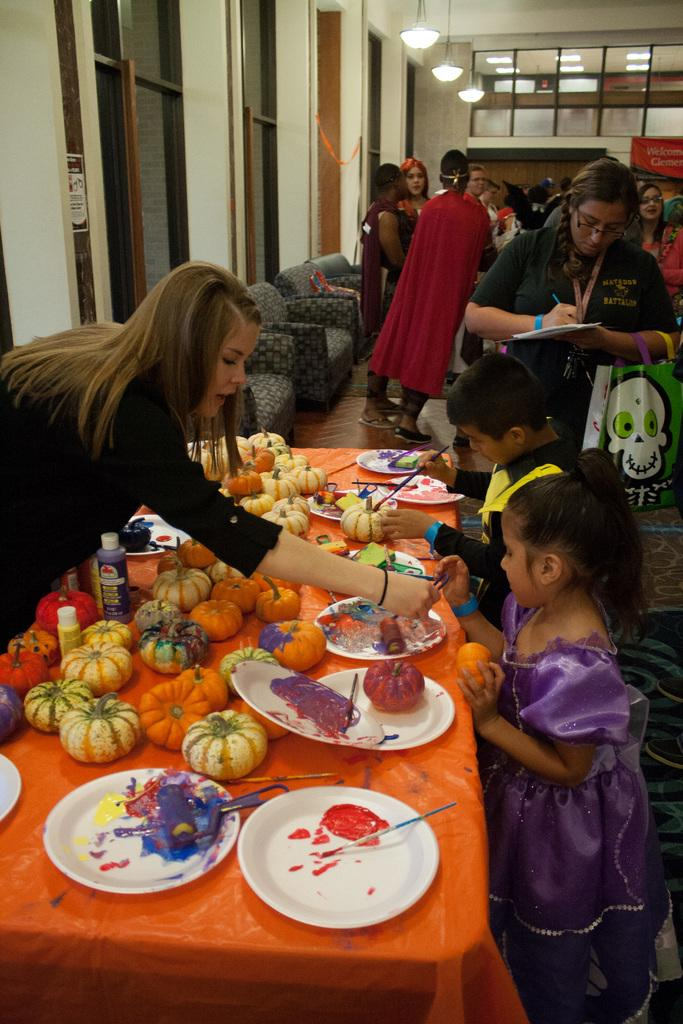What is the color of the wall in the image? The wall in the image is white. What can be seen in the image besides the wall? There are lights, people, sofas, a table, plates, colors, and pumpkins visible in the image. What type of furniture is present in the image? There are sofas in the image. What is on the table in the image? There are plates, colors, and pumpkins on the table in the image. What store can be seen in the image? There is no store present in the image. What is the best way to reach the afterthought in the image? There is no afterthought present in the image, so it cannot be reached. 